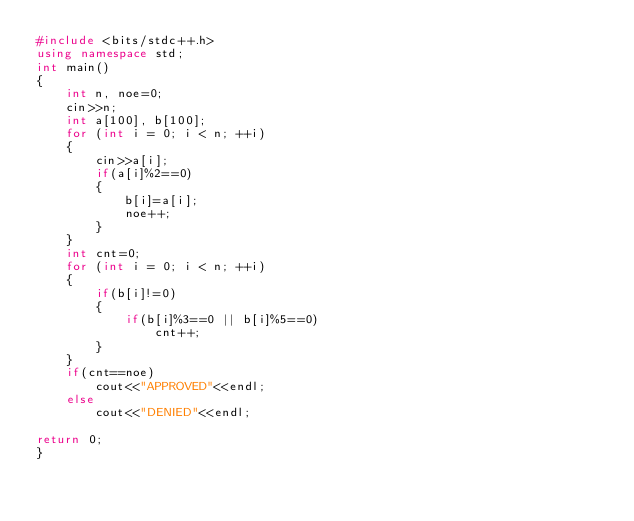<code> <loc_0><loc_0><loc_500><loc_500><_C++_>#include <bits/stdc++.h>
using namespace std;
int main()
{
	int n, noe=0;
	cin>>n;
	int a[100], b[100];
	for (int i = 0; i < n; ++i)
	{
		cin>>a[i];
		if(a[i]%2==0)
		{
			b[i]=a[i];
			noe++;
		}
	}
	int cnt=0;
	for (int i = 0; i < n; ++i)
	{
		if(b[i]!=0)
		{
			if(b[i]%3==0 || b[i]%5==0)
				cnt++;
		}
	}
	if(cnt==noe)
		cout<<"APPROVED"<<endl;
	else
		cout<<"DENIED"<<endl;

return 0;
}</code> 